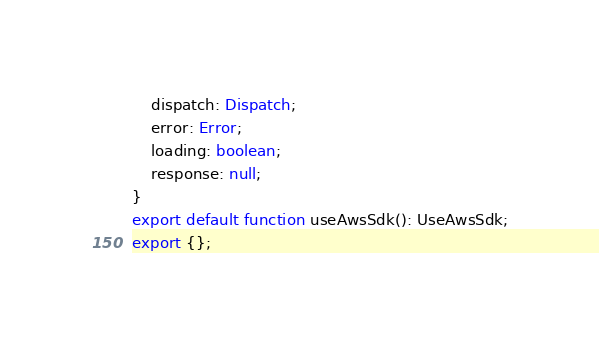<code> <loc_0><loc_0><loc_500><loc_500><_TypeScript_>    dispatch: Dispatch;
    error: Error;
    loading: boolean;
    response: null;
}
export default function useAwsSdk(): UseAwsSdk;
export {};
</code> 